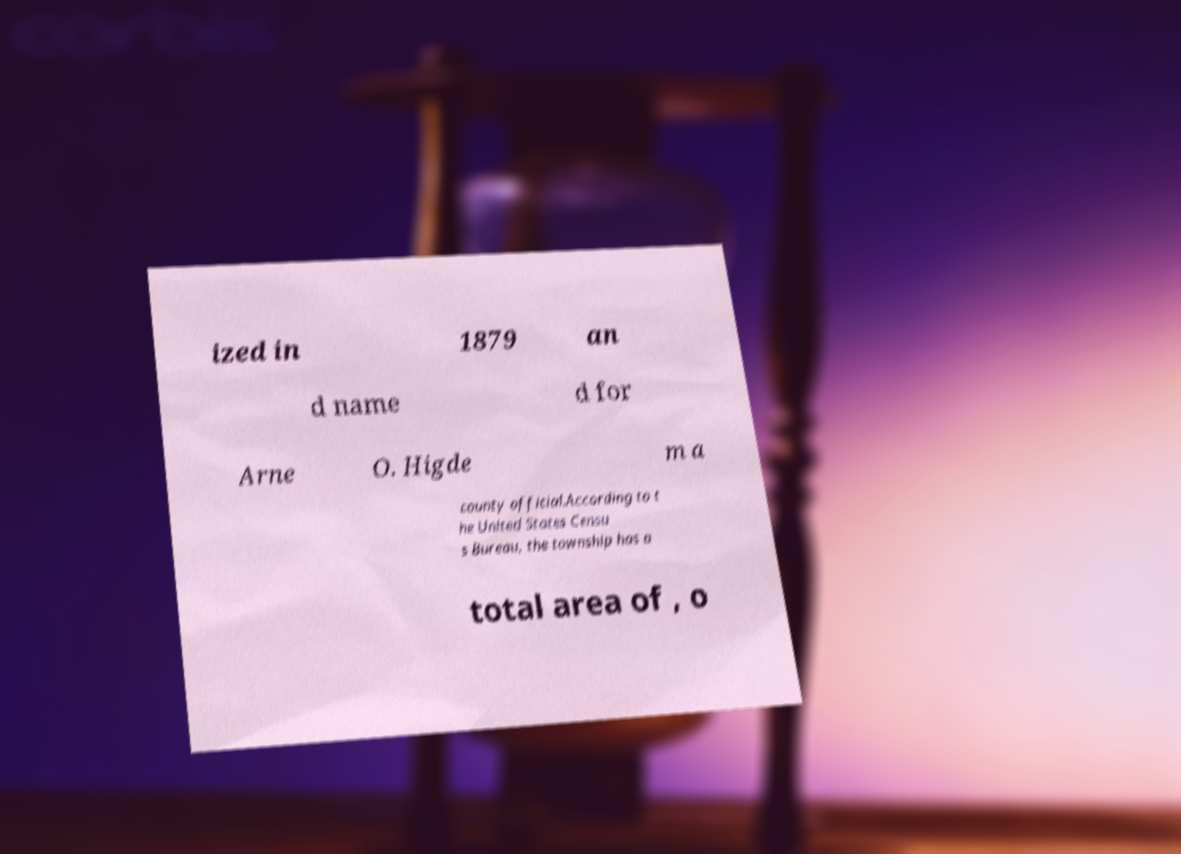Please identify and transcribe the text found in this image. ized in 1879 an d name d for Arne O. Higde m a county official.According to t he United States Censu s Bureau, the township has a total area of , o 